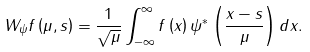Convert formula to latex. <formula><loc_0><loc_0><loc_500><loc_500>W _ { \psi } f \left ( \mu , s \right ) = \frac { 1 } { \sqrt { \mu } } \int _ { - \infty } ^ { \infty } f \left ( x \right ) \psi ^ { \ast } \left ( \frac { x - s } { \mu } \right ) d x .</formula> 